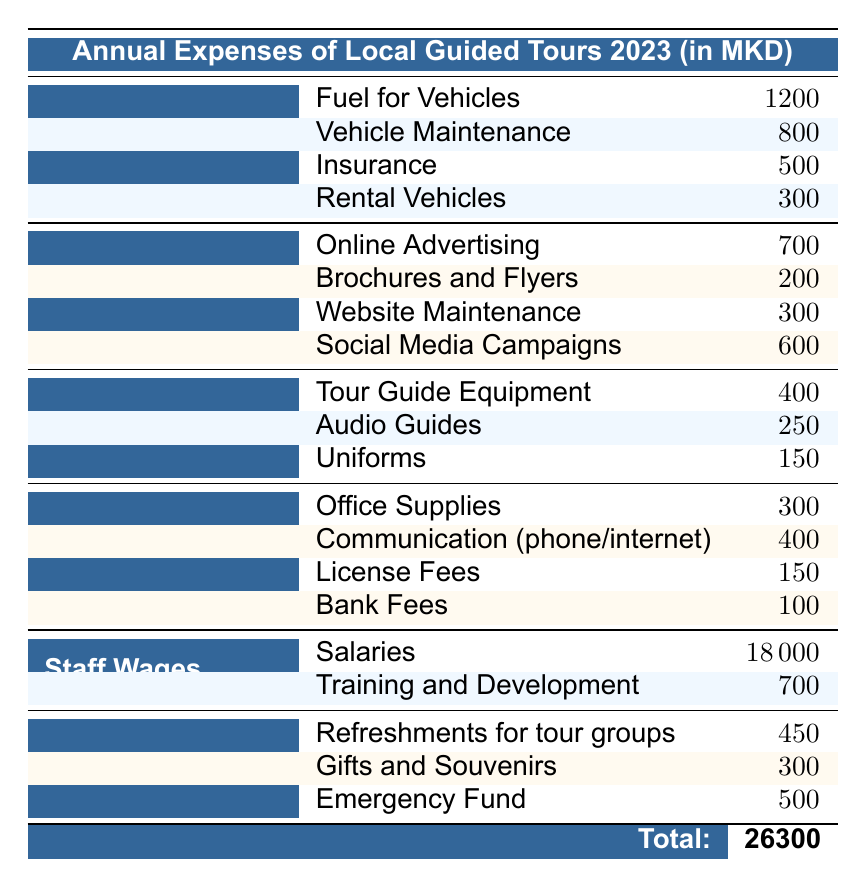What is the total expense for Transportation? To find the total expense for Transportation, we sum the costs of all items under this category: Fuel for Vehicles (1200) + Vehicle Maintenance (800) + Insurance (500) + Rental Vehicles (300) = 2800.
Answer: 2800 How much was spent on Marketing in total? We calculate the total expense for Marketing by adding the costs of all items listed in this category: Online Advertising (700) + Brochures and Flyers (200) + Website Maintenance (300) + Social Media Campaigns (600) = 1800.
Answer: 1800 Is the cost for Staff Wages greater than 20000? The total for Staff Wages includes Salaries (18000) and Training and Development (700), summing to 18700. This amount is less than 20000, so the answer is no.
Answer: No Which category has the highest single expense item? Reviewing the table, Staff Wages has the highest single item "Salaries," which costs 18000. No other item exceeds this amount, making it the highest single expense.
Answer: Salaries What is the average expense for Equipment? The total expense for Equipment is derived from Tour Guide Equipment (400) + Audio Guides (250) + Uniforms (150) = 800. There are three items, so the average is 800 divided by 3, which is approximately 266.67.
Answer: 266.67 How much more is spent on Operational Costs compared to Equipment? Operational Costs total is Office Supplies (300) + Communication (400) + License Fees (150) + Bank Fees (100) = 950. Equipment's total is 800. Therefore, the difference is 950 - 800 = 150, meaning Operational Costs are higher by 150.
Answer: 150 Was more spent on Miscellaneous or Marketing? The total for Miscellaneous is Refreshments (450) + Gifts and Souvenirs (300) + Emergency Fund (500) = 1250. The total for Marketing is 1800. Since 1250 is less than 1800, the answer is Marketing.
Answer: Marketing How many categories have total expenses over 1000? We analyze the total expenses for each category: Transportation (2800), Marketing (1800), Equipment (800), Operational Costs (950), Staff Wages (18700), and Miscellaneous (1250). Only Transportation, Marketing, and Staff Wages exceed 1000, giving us three categories.
Answer: 3 What is the largest expense for Miscellaneous? In the Miscellaneous category, we look at the individual items: Refreshments (450), Gifts and Souvenirs (300), and Emergency Fund (500). The largest expense listed is the Emergency Fund at 500.
Answer: Emergency Fund 